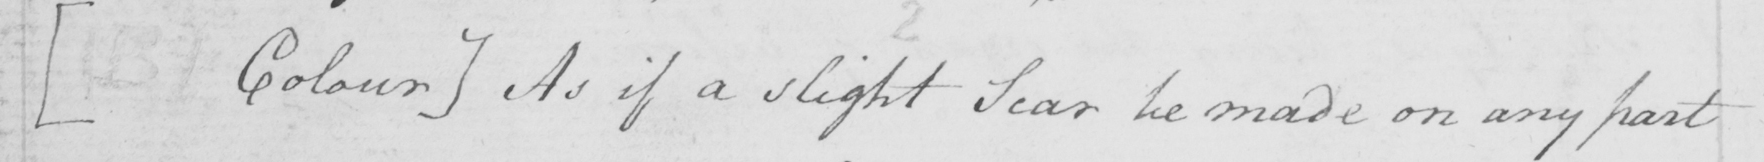Please transcribe the handwritten text in this image. [(B) Colour] As if a slight scar be made on any part 